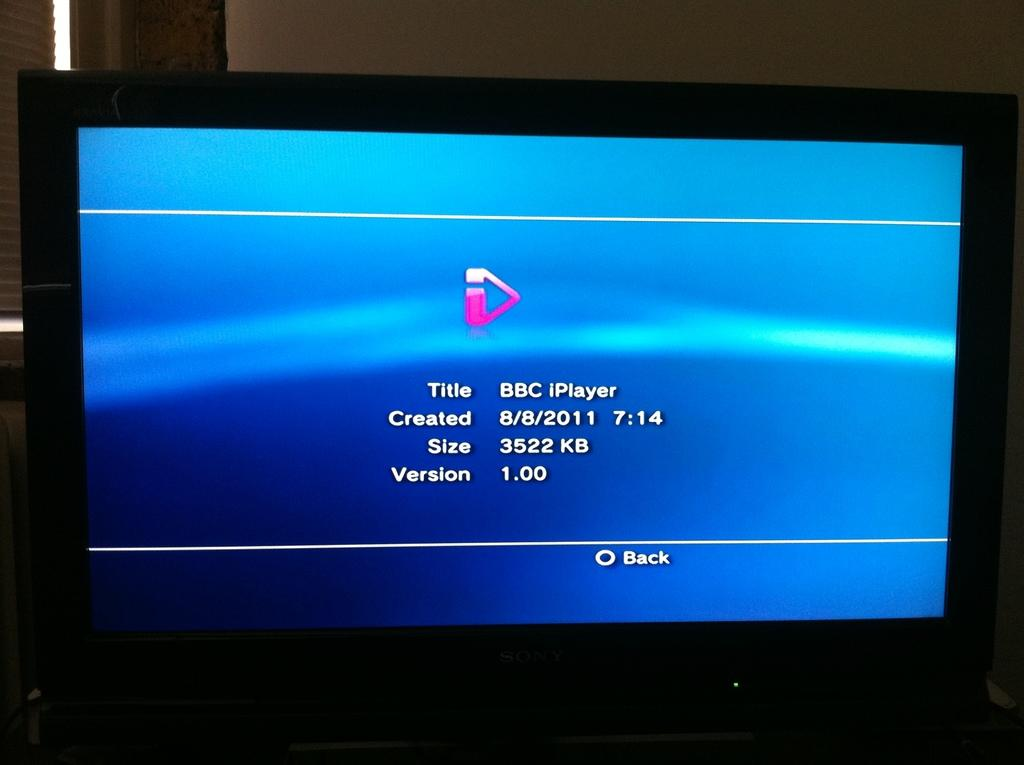Provide a one-sentence caption for the provided image. A tv monitor displays details about a file that is 3522 kb in size. 